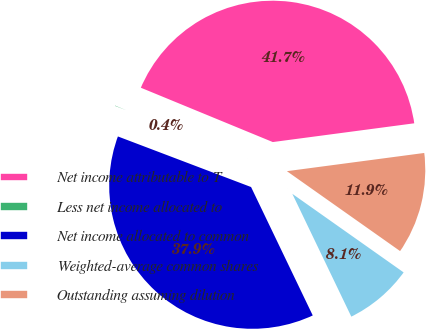<chart> <loc_0><loc_0><loc_500><loc_500><pie_chart><fcel>Net income attributable to T<fcel>Less net income allocated to<fcel>Net income allocated to common<fcel>Weighted-average common shares<fcel>Outstanding assuming dilution<nl><fcel>41.68%<fcel>0.44%<fcel>37.9%<fcel>8.09%<fcel>11.88%<nl></chart> 